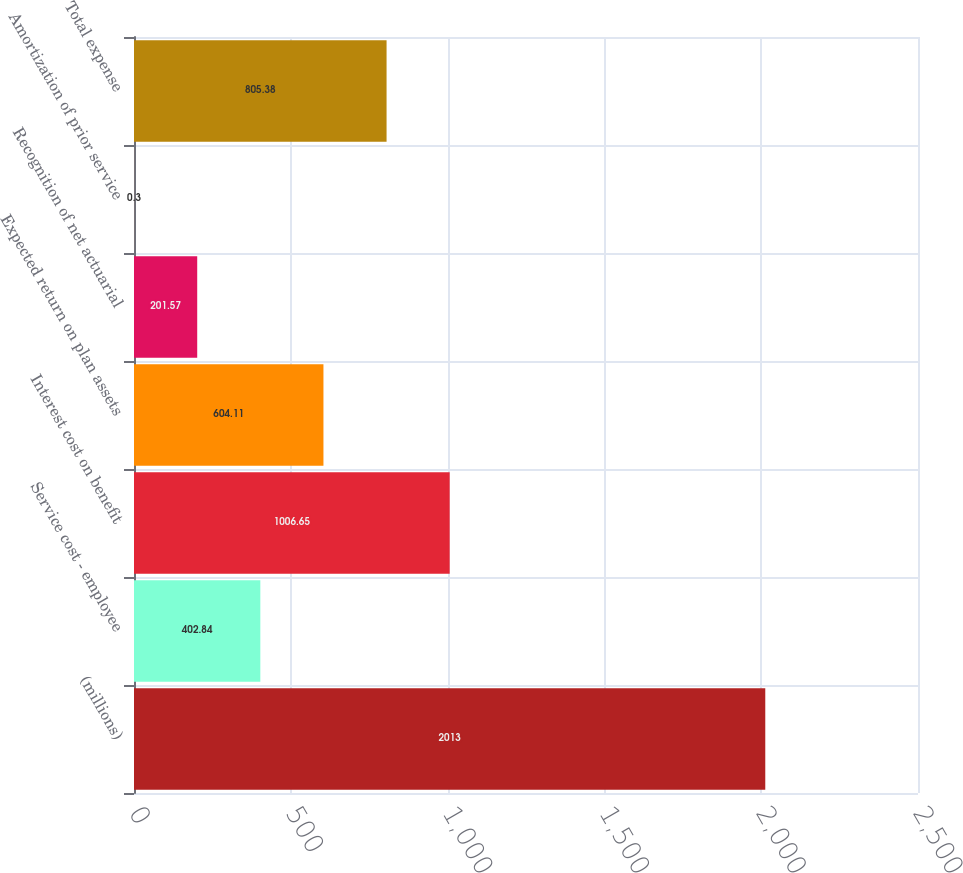Convert chart. <chart><loc_0><loc_0><loc_500><loc_500><bar_chart><fcel>(millions)<fcel>Service cost - employee<fcel>Interest cost on benefit<fcel>Expected return on plan assets<fcel>Recognition of net actuarial<fcel>Amortization of prior service<fcel>Total expense<nl><fcel>2013<fcel>402.84<fcel>1006.65<fcel>604.11<fcel>201.57<fcel>0.3<fcel>805.38<nl></chart> 